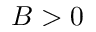Convert formula to latex. <formula><loc_0><loc_0><loc_500><loc_500>B > 0</formula> 